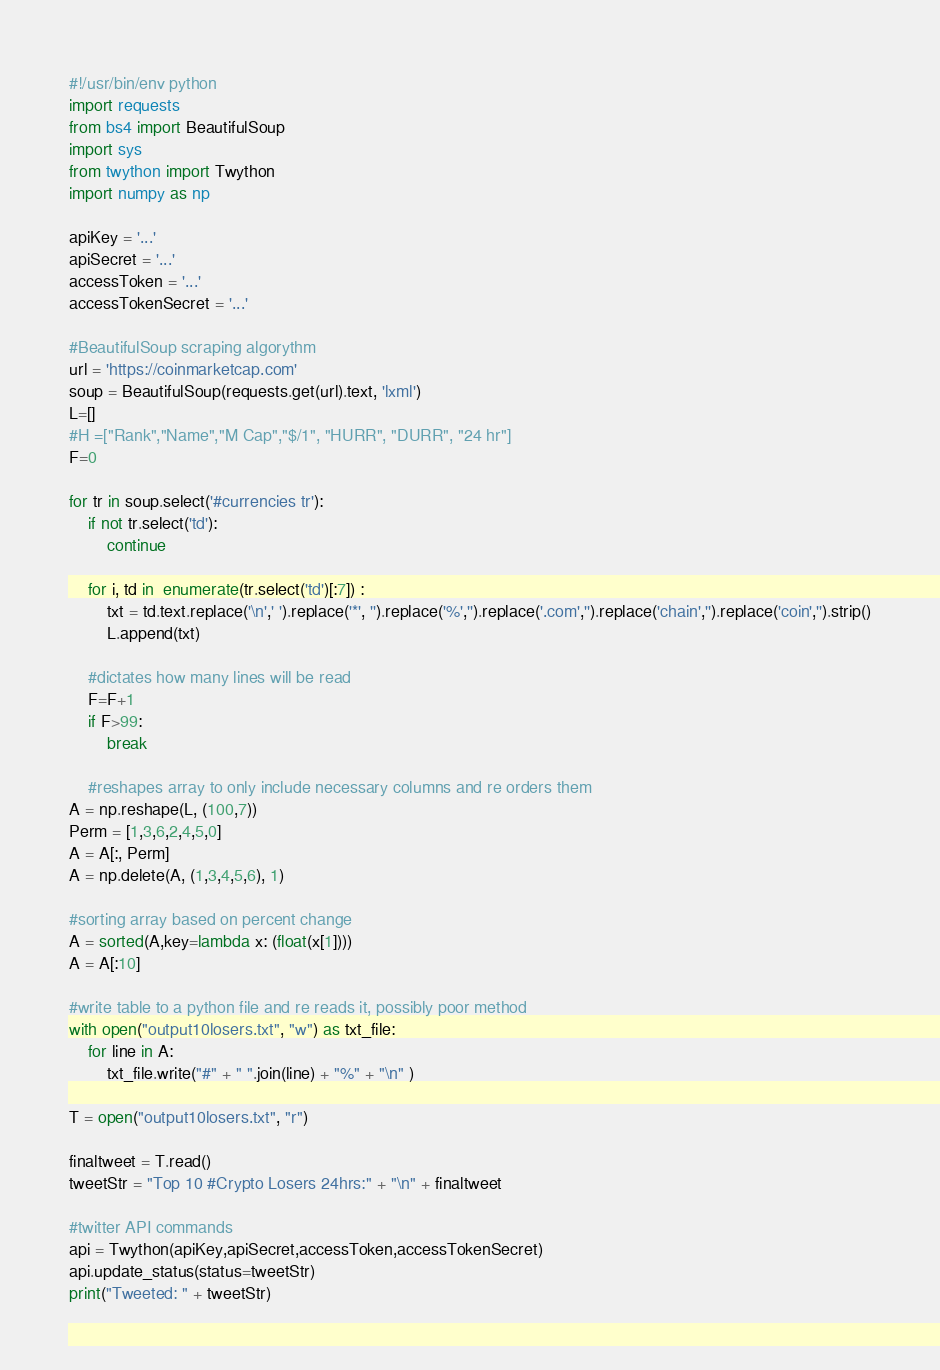Convert code to text. <code><loc_0><loc_0><loc_500><loc_500><_Python_>#!/usr/bin/env python
import requests
from bs4 import BeautifulSoup
import sys
from twython import Twython
import numpy as np

apiKey = '...'
apiSecret = '...'
accessToken = '...'
accessTokenSecret = '...'

#BeautifulSoup scraping algorythm
url = 'https://coinmarketcap.com'
soup = BeautifulSoup(requests.get(url).text, 'lxml')
L=[]
#H =["Rank","Name","M Cap","$/1", "HURR", "DURR", "24 hr"] 
F=0

for tr in soup.select('#currencies tr'):
    if not tr.select('td'):
        continue

    for i, td in  enumerate(tr.select('td')[:7]) :
        txt = td.text.replace('\n',' ').replace('*', '').replace('%','').replace('.com','').replace('chain','').replace('coin','').strip()
        L.append(txt)
        
    #dictates how many lines will be read
    F=F+1  
    if F>99:
        break
    
    #reshapes array to only include necessary columns and re orders them
A = np.reshape(L, (100,7))    
Perm = [1,3,6,2,4,5,0]
A = A[:, Perm]
A = np.delete(A, (1,3,4,5,6), 1)

#sorting array based on percent change
A = sorted(A,key=lambda x: (float(x[1])))
A = A[:10]

#write table to a python file and re reads it, possibly poor method
with open("output10losers.txt", "w") as txt_file:
    for line in A:
        txt_file.write("#" + " ".join(line) + "%" + "\n" )

T = open("output10losers.txt", "r")

finaltweet = T.read()
tweetStr = "Top 10 #Crypto Losers 24hrs:" + "\n" + finaltweet

#twitter API commands
api = Twython(apiKey,apiSecret,accessToken,accessTokenSecret)
api.update_status(status=tweetStr)
print("Tweeted: " + tweetStr)

</code> 